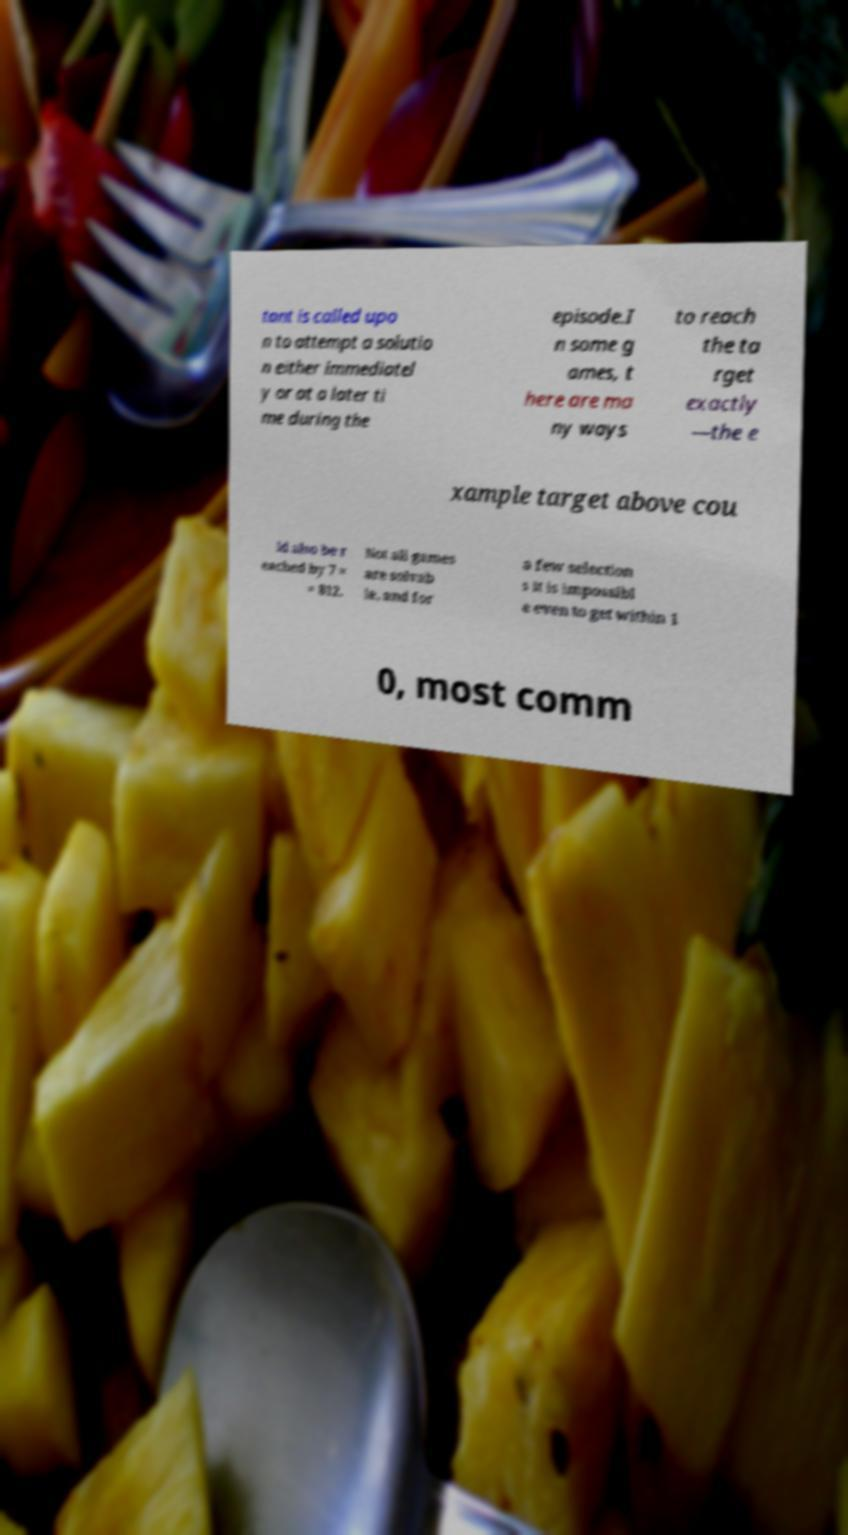Can you accurately transcribe the text from the provided image for me? tant is called upo n to attempt a solutio n either immediatel y or at a later ti me during the episode.I n some g ames, t here are ma ny ways to reach the ta rget exactly —the e xample target above cou ld also be r eached by 7 × = 812. Not all games are solvab le, and for a few selection s it is impossibl e even to get within 1 0, most comm 